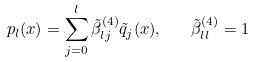Convert formula to latex. <formula><loc_0><loc_0><loc_500><loc_500>p _ { l } ( x ) = \sum _ { j = 0 } ^ { l } \tilde { \beta } _ { l j } ^ { ( 4 ) } \tilde { q } _ { j } ( x ) , \quad \tilde { \beta } _ { l l } ^ { ( 4 ) } = 1</formula> 